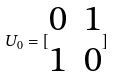Convert formula to latex. <formula><loc_0><loc_0><loc_500><loc_500>U _ { 0 } = [ \begin{matrix} 0 & 1 \\ 1 & 0 \end{matrix} ]</formula> 